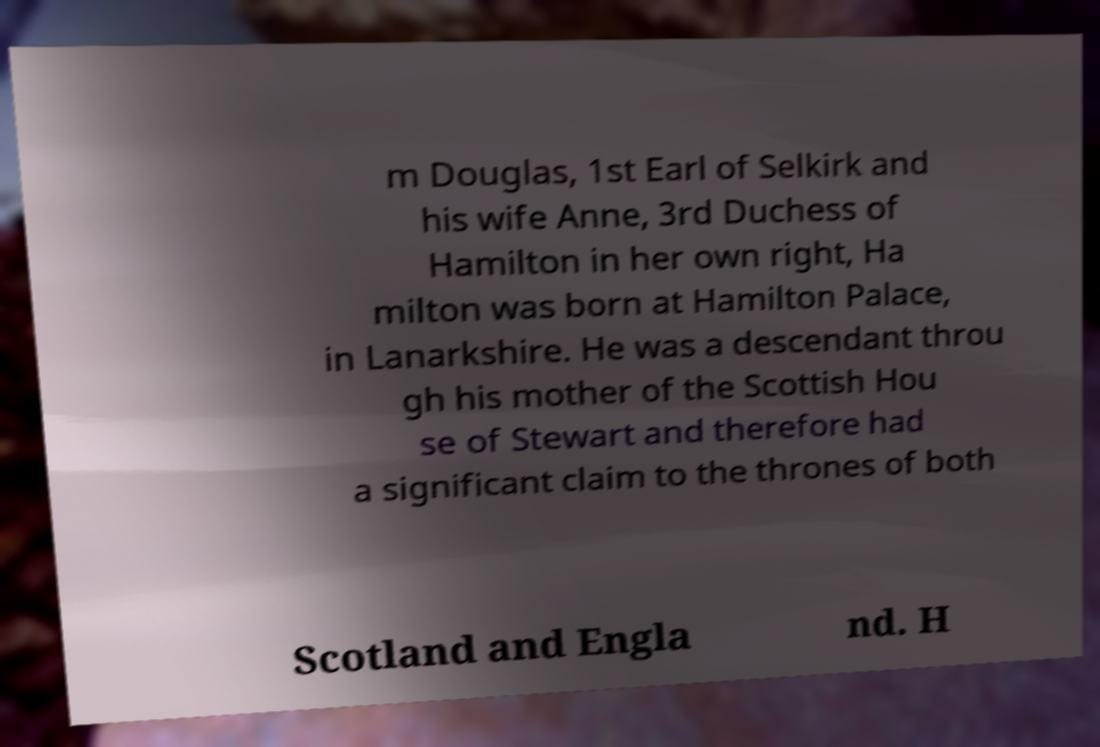Please read and relay the text visible in this image. What does it say? m Douglas, 1st Earl of Selkirk and his wife Anne, 3rd Duchess of Hamilton in her own right, Ha milton was born at Hamilton Palace, in Lanarkshire. He was a descendant throu gh his mother of the Scottish Hou se of Stewart and therefore had a significant claim to the thrones of both Scotland and Engla nd. H 